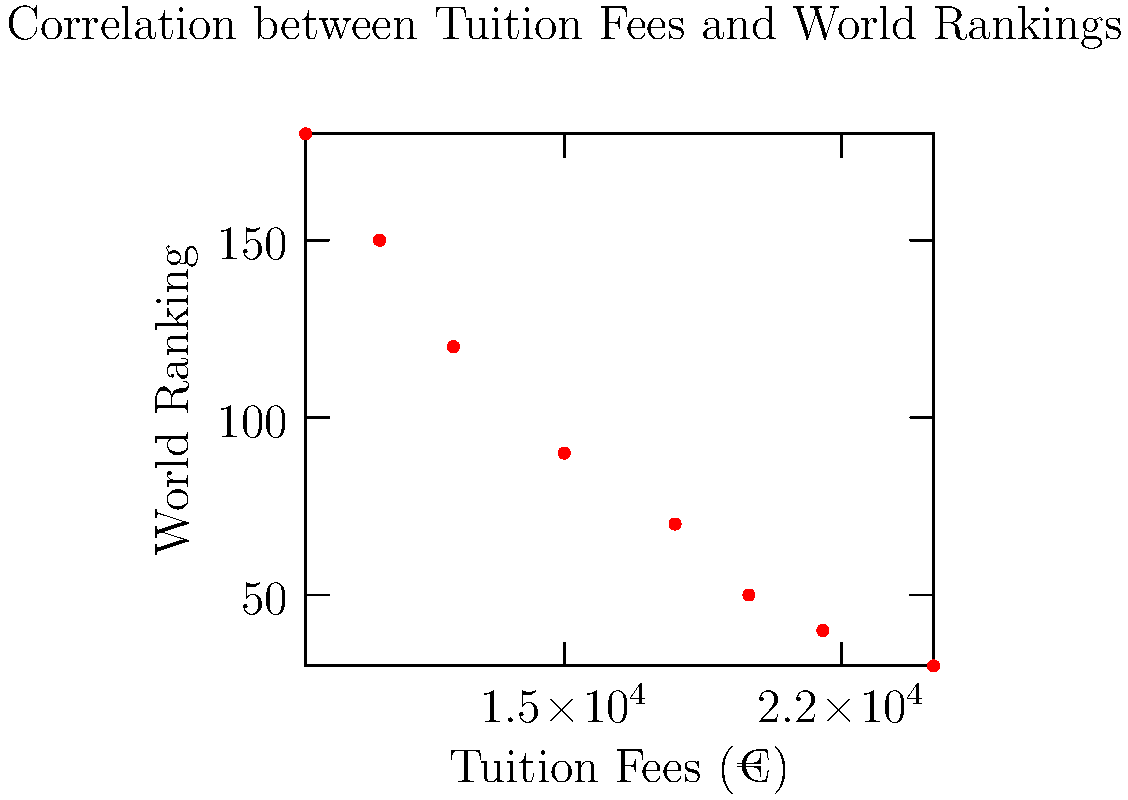Based on the scatter plot showing the correlation between tuition fees and world rankings of French engineering schools, what can be inferred about the relationship between these two variables? To interpret the scatter plot and determine the relationship between tuition fees and world rankings of French engineering schools, we need to follow these steps:

1. Observe the overall trend: As we move from left to right (increasing tuition fees), the points generally move downward (decreasing world ranking numbers).

2. Understand the ranking system: Lower numbers in world rankings indicate better-ranked schools (e.g., a rank of 30 is better than a rank of 180).

3. Analyze the correlation: The downward trend suggests a negative correlation between tuition fees and world ranking numbers. This means that as tuition fees increase, the world ranking numbers decrease (improve).

4. Interpret the relationship: Higher tuition fees are associated with better (lower) world rankings. This suggests that more expensive French engineering schools tend to have better world rankings.

5. Consider the strength of the relationship: The points form a relatively clear pattern, indicating a moderately strong correlation between tuition fees and world rankings.

6. Note any outliers or exceptions: There don't appear to be any significant outliers in this data set, which strengthens the observed relationship.

Based on these observations, we can conclude that there is a negative correlation between tuition fees and world ranking numbers, implying that higher tuition fees are generally associated with better (lower) world rankings for French engineering schools.
Answer: Negative correlation; higher tuition fees associated with better (lower) world rankings. 